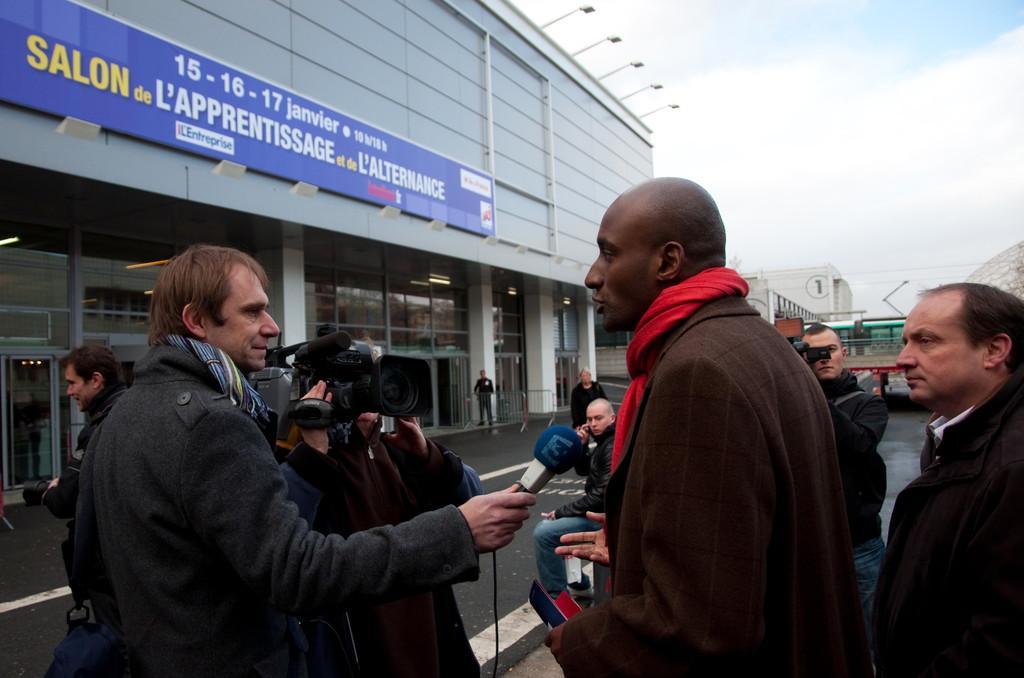Please provide a concise description of this image. In this image, we can see people wearing scarves and one of them is holding a mic and some are holding cameras. In the background, there are buildings, lights, name boards, railings, poles along with wires and we can see vehicles. At the bottom, there is road and at the top, there is sky. 